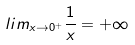Convert formula to latex. <formula><loc_0><loc_0><loc_500><loc_500>l i m _ { x \rightarrow 0 ^ { + } } \frac { 1 } { x } = + \infty</formula> 